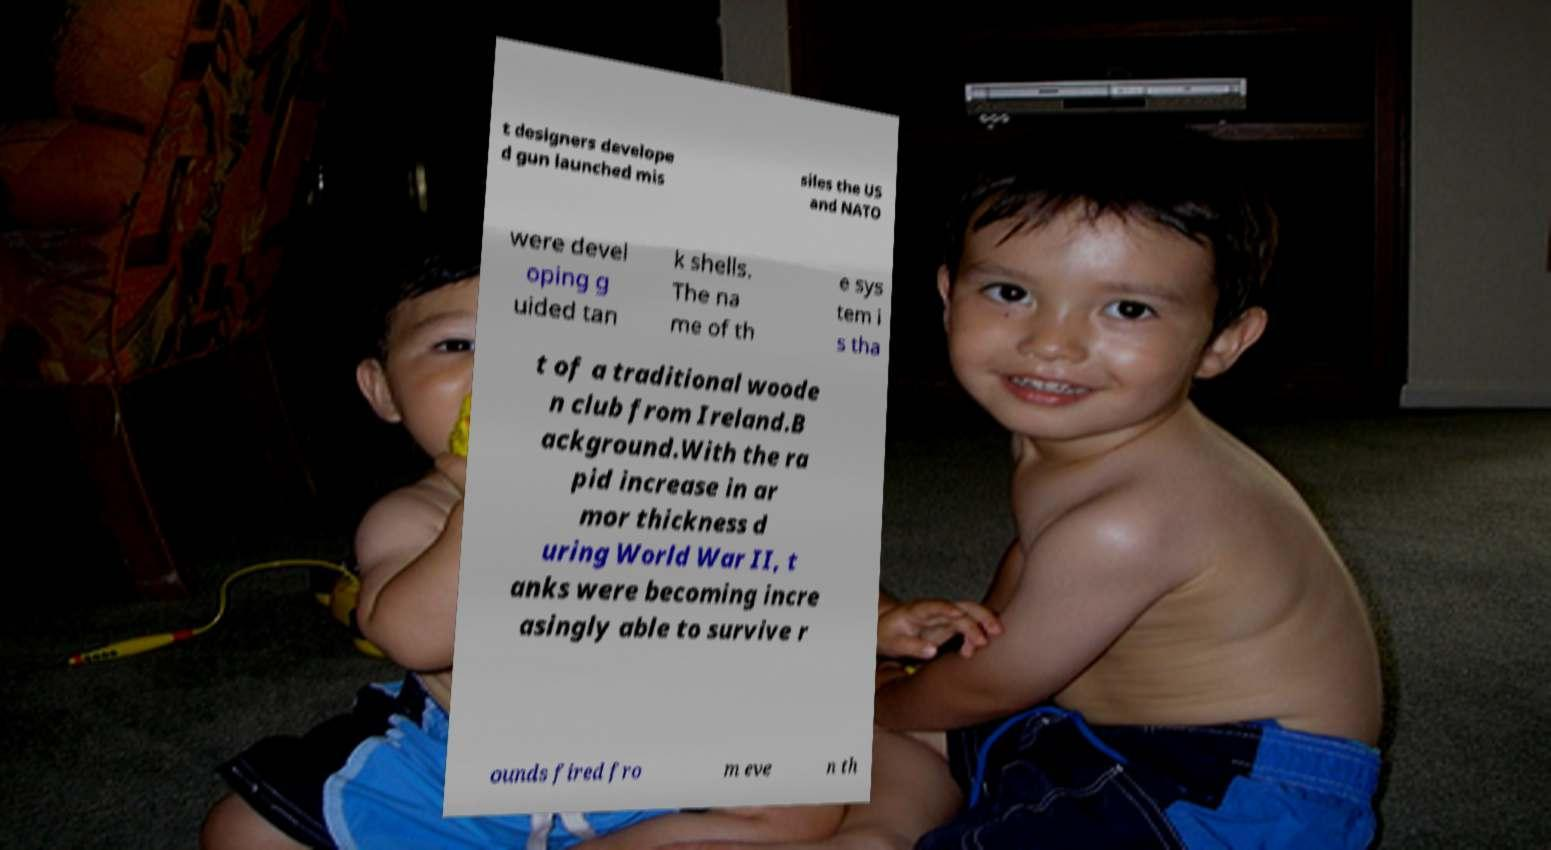There's text embedded in this image that I need extracted. Can you transcribe it verbatim? t designers develope d gun launched mis siles the US and NATO were devel oping g uided tan k shells. The na me of th e sys tem i s tha t of a traditional woode n club from Ireland.B ackground.With the ra pid increase in ar mor thickness d uring World War II, t anks were becoming incre asingly able to survive r ounds fired fro m eve n th 